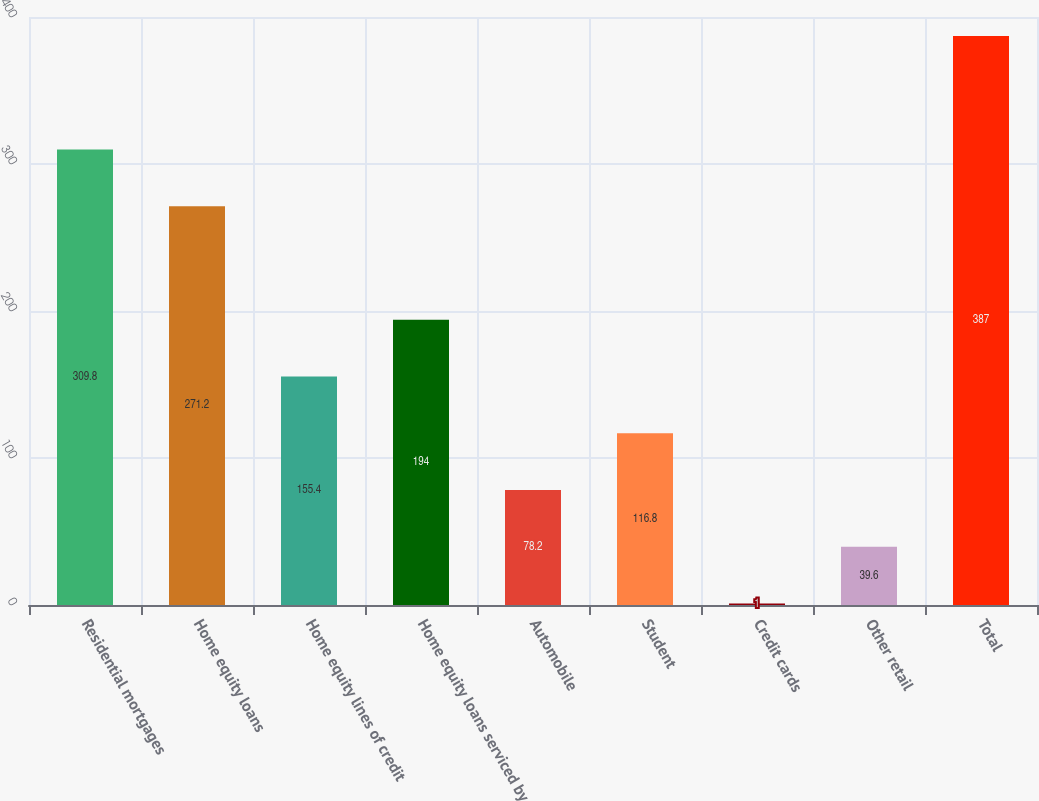Convert chart. <chart><loc_0><loc_0><loc_500><loc_500><bar_chart><fcel>Residential mortgages<fcel>Home equity loans<fcel>Home equity lines of credit<fcel>Home equity loans serviced by<fcel>Automobile<fcel>Student<fcel>Credit cards<fcel>Other retail<fcel>Total<nl><fcel>309.8<fcel>271.2<fcel>155.4<fcel>194<fcel>78.2<fcel>116.8<fcel>1<fcel>39.6<fcel>387<nl></chart> 